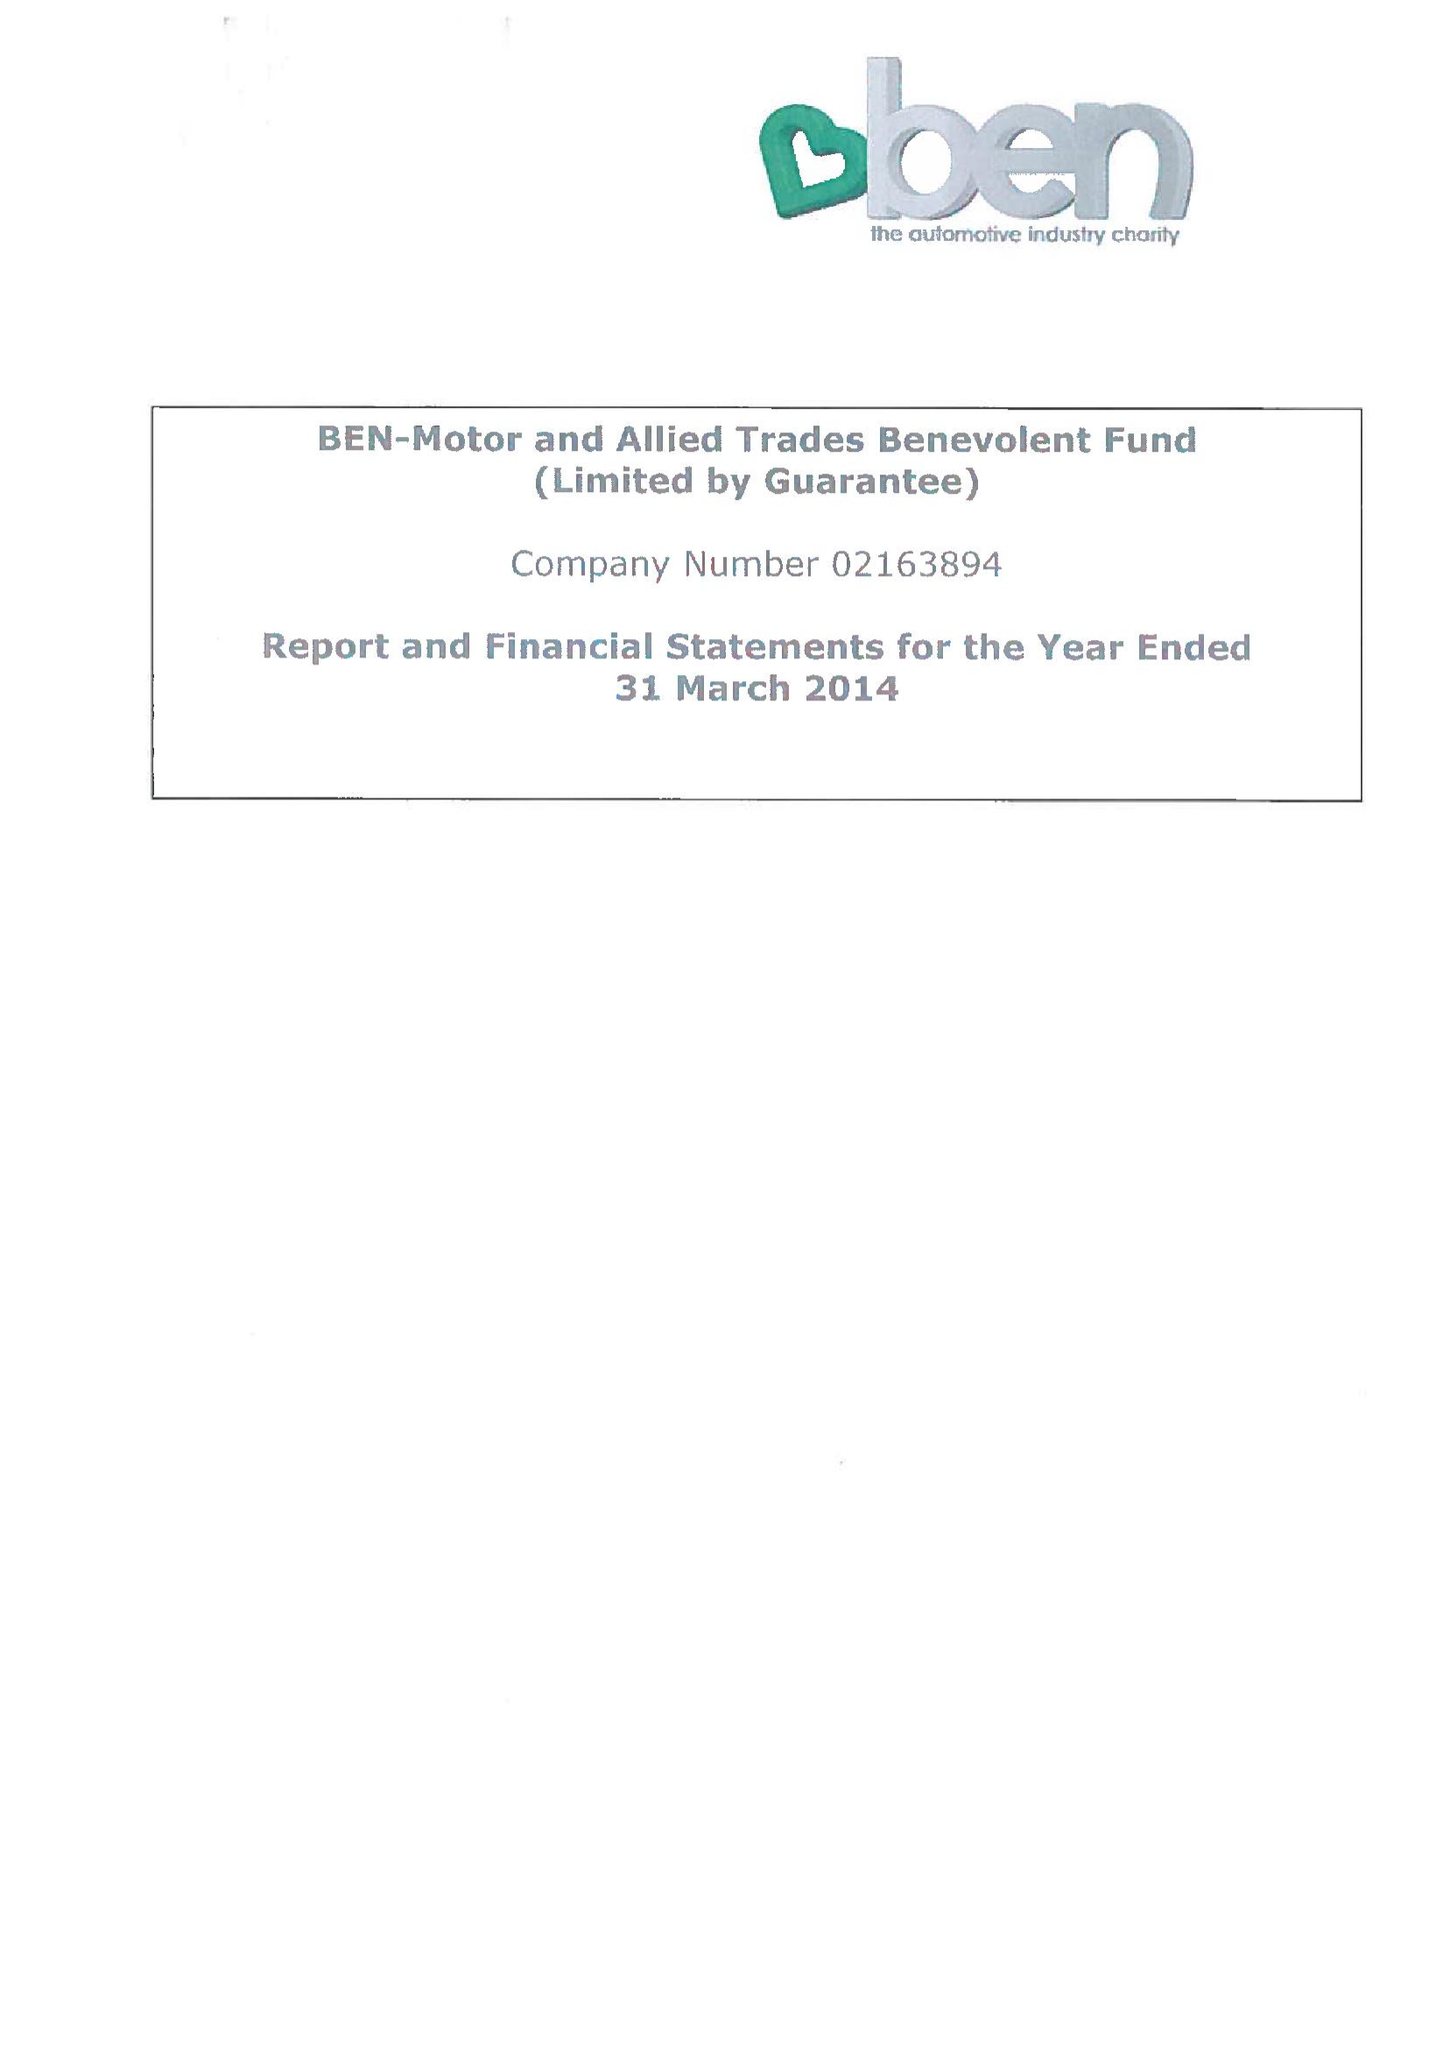What is the value for the report_date?
Answer the question using a single word or phrase. 2014-03-31 